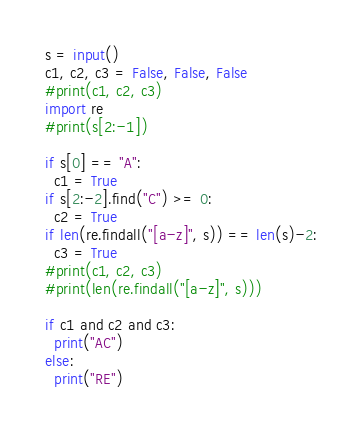Convert code to text. <code><loc_0><loc_0><loc_500><loc_500><_Python_>s = input()
c1, c2, c3 = False, False, False
#print(c1, c2, c3)
import re
#print(s[2:-1])

if s[0] == "A":
  c1 = True
if s[2:-2].find("C") >= 0:
  c2 = True
if len(re.findall("[a-z]", s)) == len(s)-2:
  c3 = True
#print(c1, c2, c3)
#print(len(re.findall("[a-z]", s)))

if c1 and c2 and c3:
  print("AC")
else:
  print("RE")</code> 